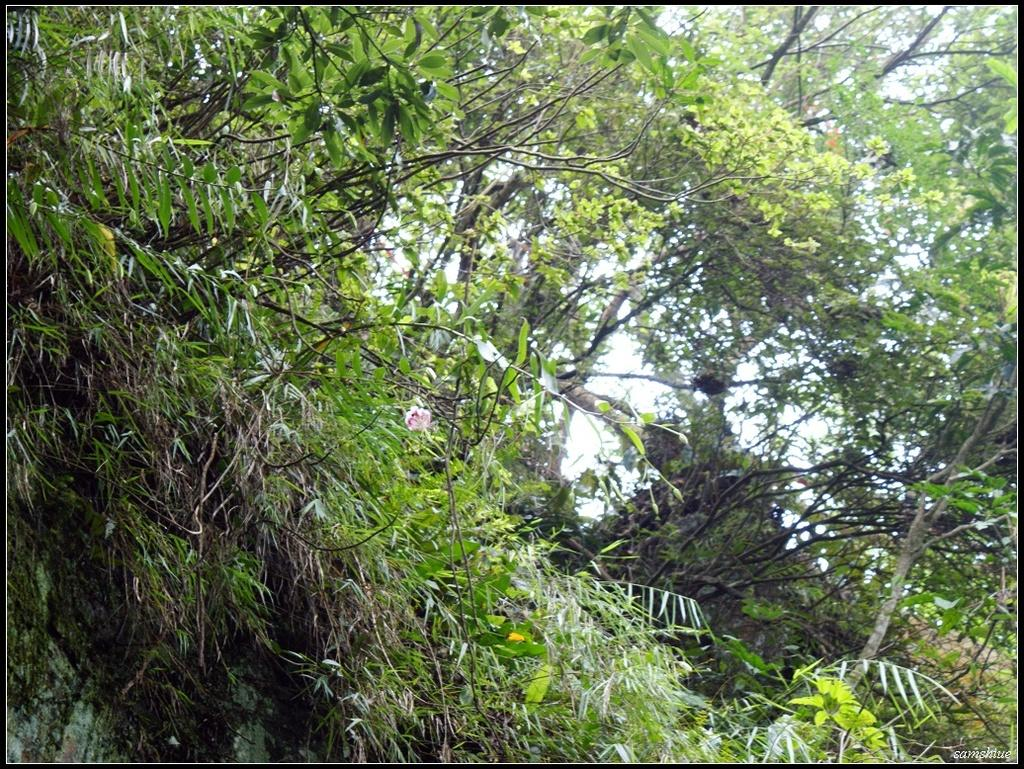What type of vegetation can be seen in the image? There are branches of different trees in the image. What is visible in the background of the image? The sky is visible in the background of the image. What type of collar can be seen on the branches in the image? There is no collar present on the branches in the image. Is there a gun visible in the image? There is no gun present in the image; it features branches of different trees and the sky. 